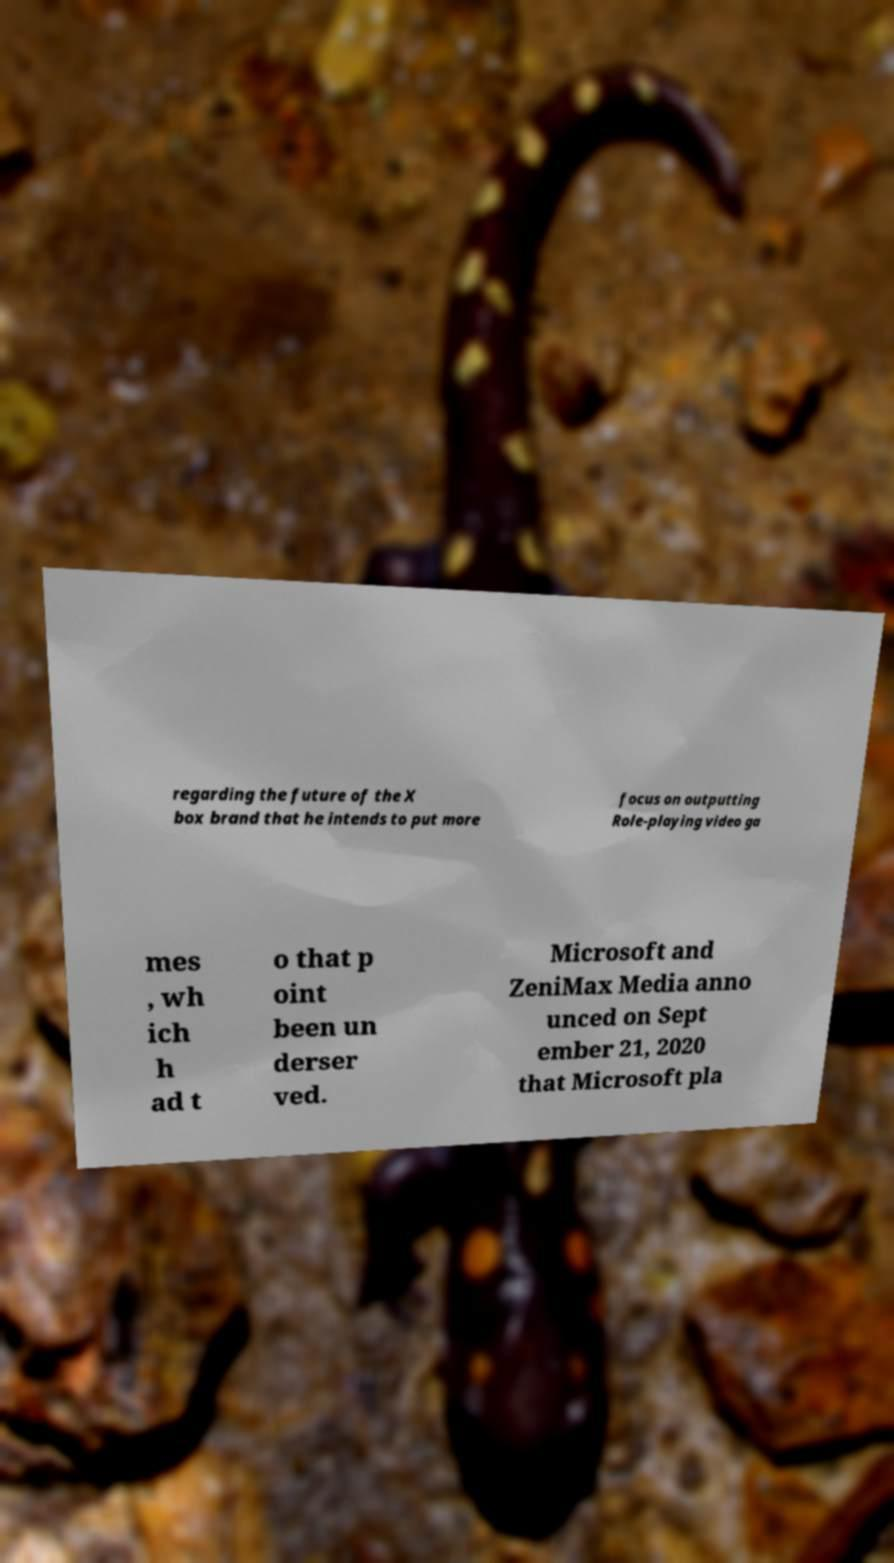For documentation purposes, I need the text within this image transcribed. Could you provide that? regarding the future of the X box brand that he intends to put more focus on outputting Role-playing video ga mes , wh ich h ad t o that p oint been un derser ved. Microsoft and ZeniMax Media anno unced on Sept ember 21, 2020 that Microsoft pla 